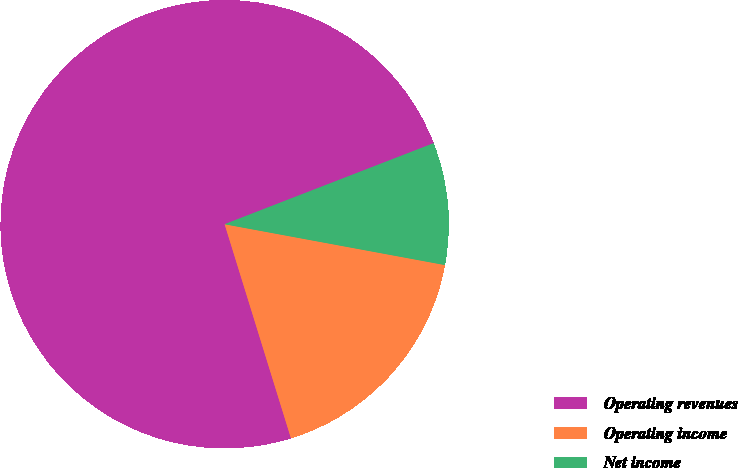Convert chart. <chart><loc_0><loc_0><loc_500><loc_500><pie_chart><fcel>Operating revenues<fcel>Operating income<fcel>Net income<nl><fcel>73.89%<fcel>17.3%<fcel>8.8%<nl></chart> 